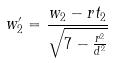Convert formula to latex. <formula><loc_0><loc_0><loc_500><loc_500>w _ { 2 } ^ { \prime } = \frac { w _ { 2 } - r t _ { 2 } } { \sqrt { 7 - \frac { r ^ { 2 } } { d ^ { 2 } } } }</formula> 